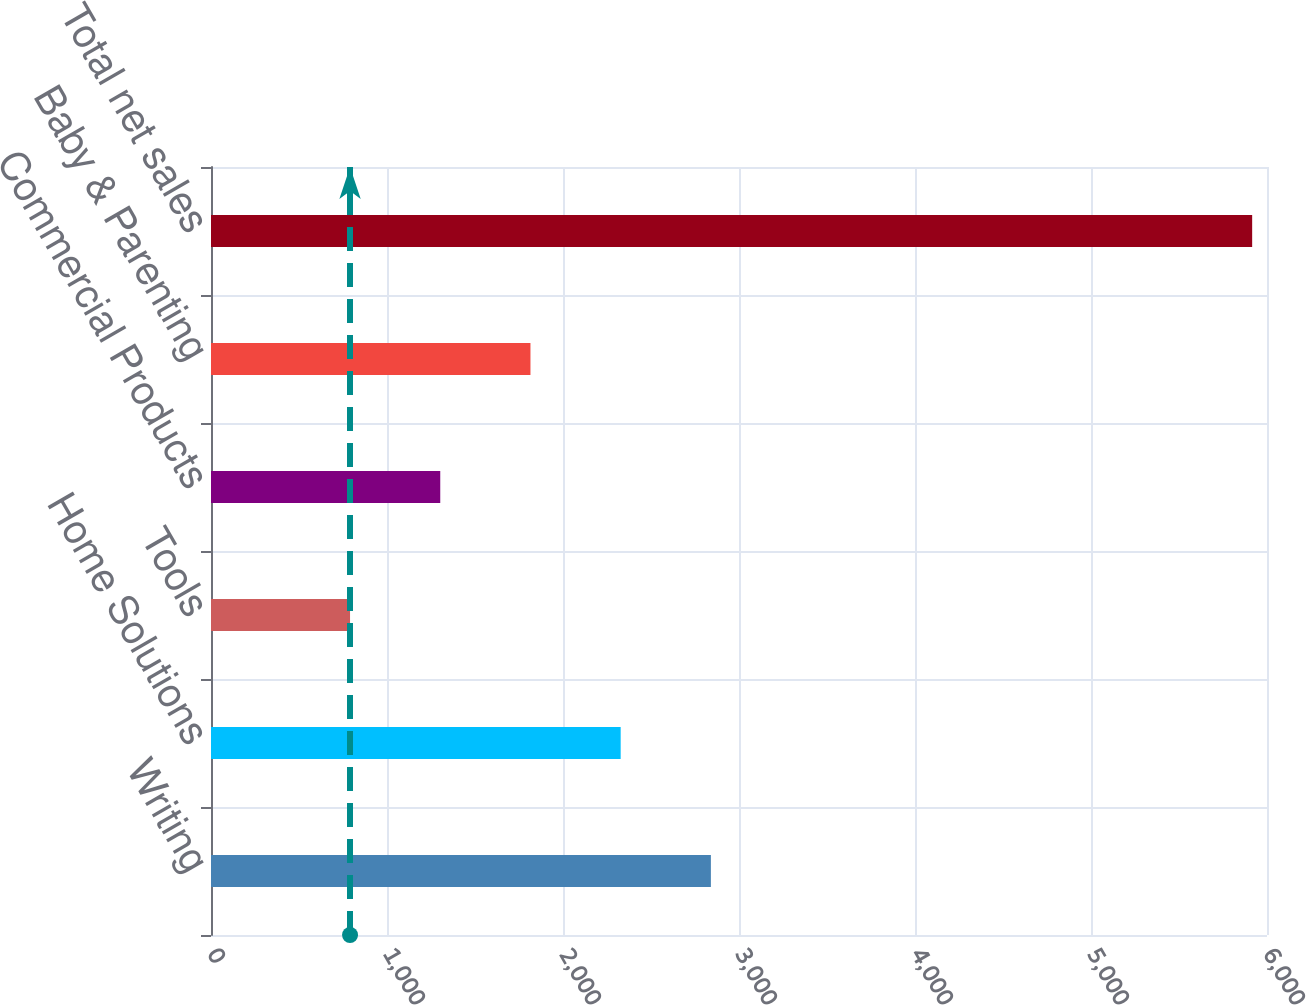<chart> <loc_0><loc_0><loc_500><loc_500><bar_chart><fcel>Writing<fcel>Home Solutions<fcel>Tools<fcel>Commercial Products<fcel>Baby & Parenting<fcel>Total net sales<nl><fcel>2840.28<fcel>2327.71<fcel>790<fcel>1302.57<fcel>1815.14<fcel>5915.7<nl></chart> 